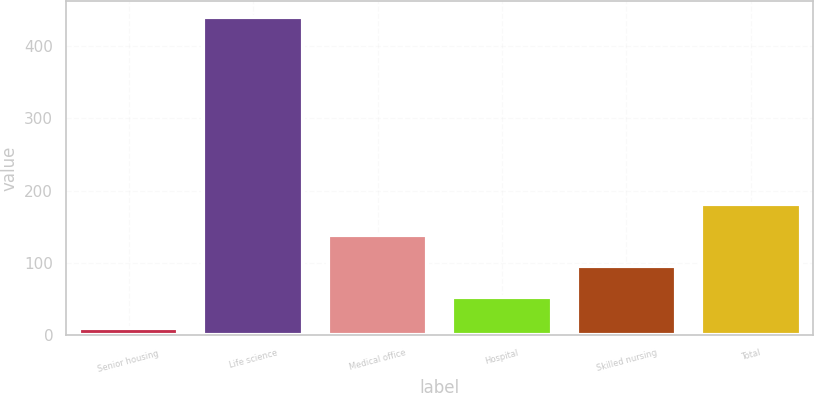<chart> <loc_0><loc_0><loc_500><loc_500><bar_chart><fcel>Senior housing<fcel>Life science<fcel>Medical office<fcel>Hospital<fcel>Skilled nursing<fcel>Total<nl><fcel>10<fcel>440<fcel>139<fcel>53<fcel>96<fcel>182<nl></chart> 